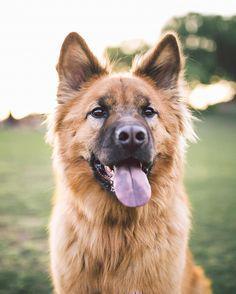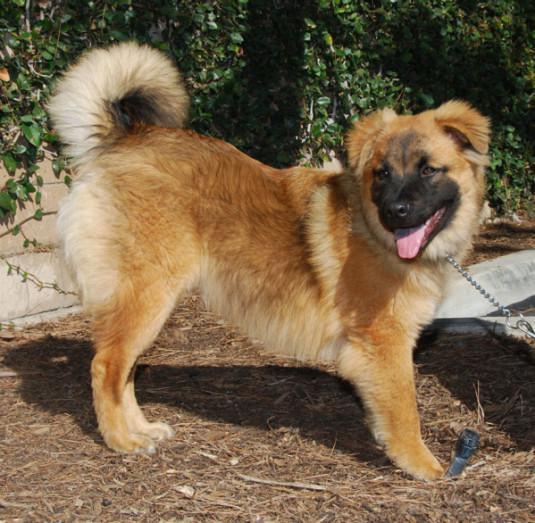The first image is the image on the left, the second image is the image on the right. Analyze the images presented: Is the assertion "At least one of the dogs is indoors." valid? Answer yes or no. No. The first image is the image on the left, the second image is the image on the right. Examine the images to the left and right. Is the description "In one image a dog is lying down on a raised surface." accurate? Answer yes or no. No. 